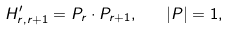Convert formula to latex. <formula><loc_0><loc_0><loc_500><loc_500>H ^ { \prime } _ { r , r + 1 } = { P } _ { r } \cdot { P } _ { r + 1 } , \quad | { P } | = 1 ,</formula> 